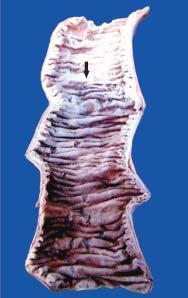s the affected part soft, swollen and dark?
Answer the question using a single word or phrase. Yes 